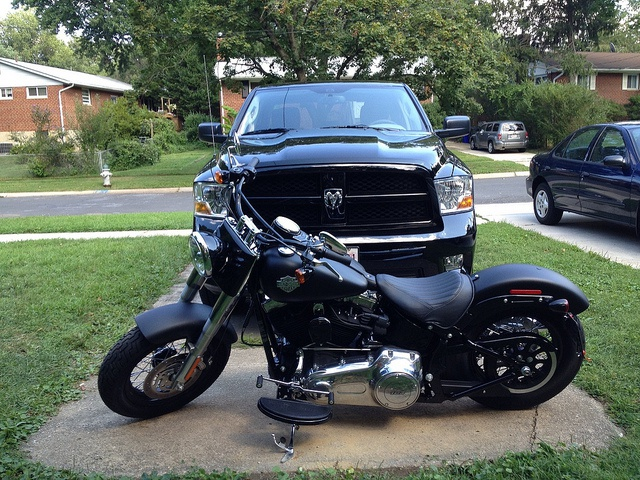Describe the objects in this image and their specific colors. I can see motorcycle in white, black, gray, and navy tones, truck in white, black, darkgray, and lightblue tones, car in white, black, gray, navy, and blue tones, car in white, gray, black, darkgray, and lightgray tones, and fire hydrant in white, darkgray, and gray tones in this image. 